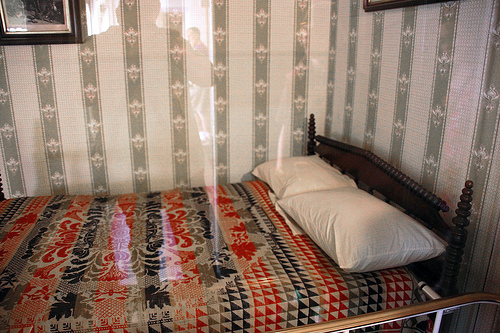Can you describe the patterns observed on the quilt? The quilt on the bed features a rich array of patterns including geometric line motifs and stylized floral and animal designs, showcasing vibrant reds, blacks, and whites. This blend of patterns could imply a mix of cultural or artistic influences. Does the quilt on the bed have any noticeable wear or ageing? The quilt shows signs of gentle wear, potentially indicating its age and frequent use. This wear adds to the vintage charm of the room and suggests that the quilt may have been cherished and used over many years. 